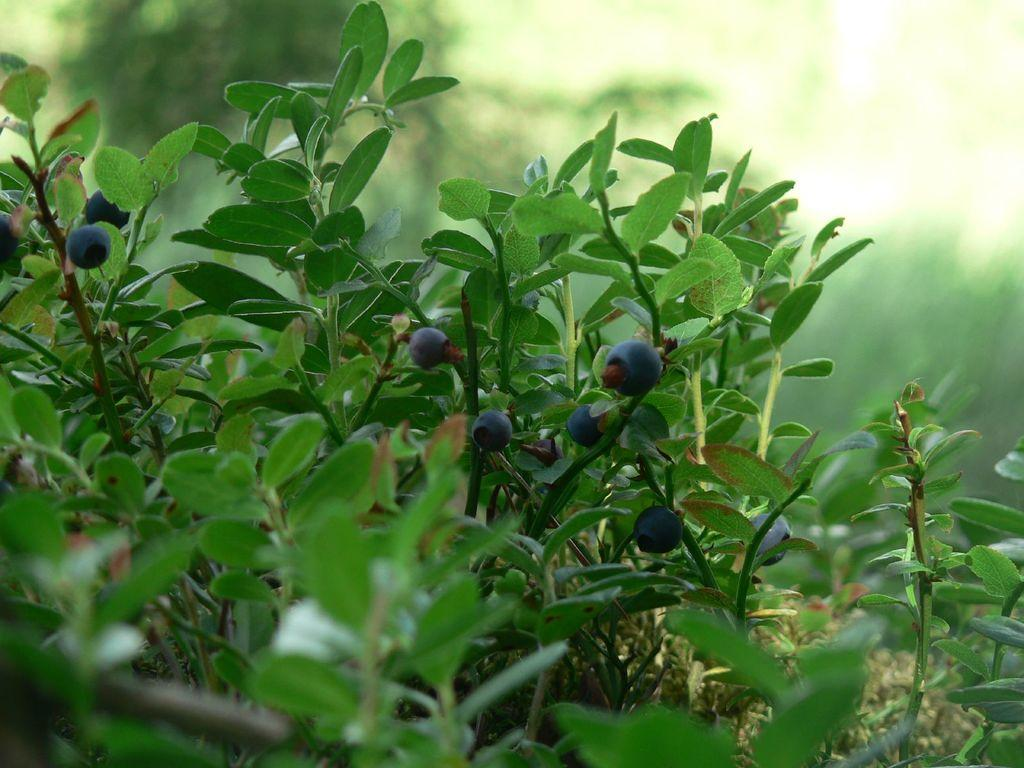What type of living organisms can be seen in the image? Plants can be seen in the image. What are the plants producing? There are berries in the image. Can you describe the background of the image? The background of the image is blurred. What type of bean is being tested by the spy in the image? There is no bean, test, or spy present in the image. 